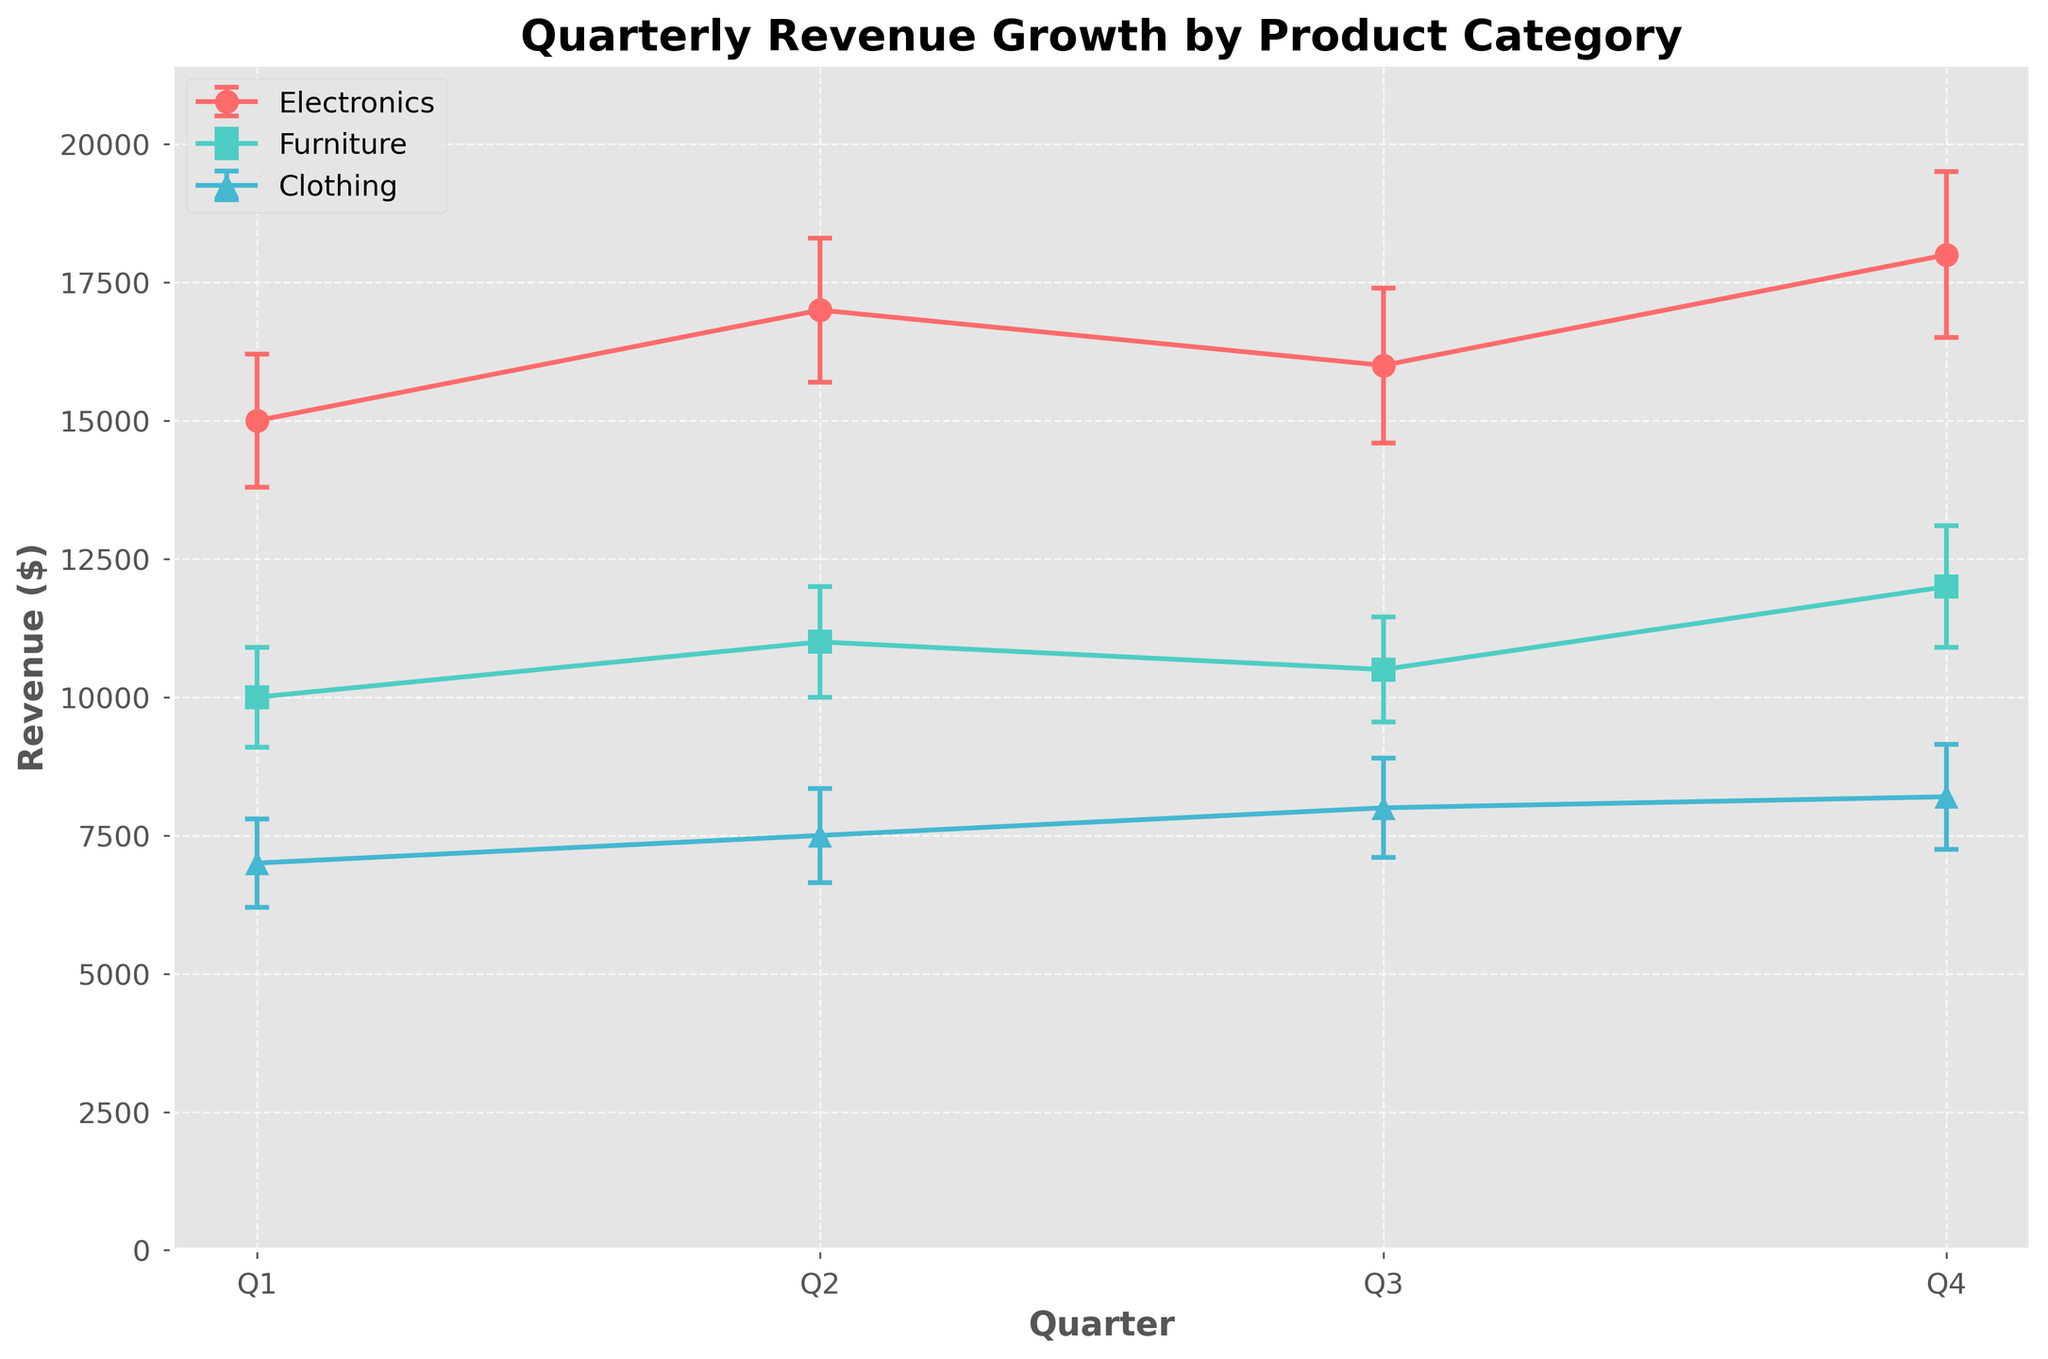Quarterly Revenue Growth by Product Category The title of the figure is centered at the top and indicates what the figure is about
Answer: Quarterly Revenue Growth by Product Category What are the categories compared in the figure? The figure shows separate lines for each product category, indicated by different colors and markers in the legend
Answer: Electronics, Furniture, Clothing Which quarter has the highest revenue for Electronics? By looking at the Electronics line, the revenue is highest in Q4, with the data point reaching its peak in Q4
Answer: Q4 What is the revenue for Furniture in Q2? Referring to the Furniture line, the revenue value for Q2 is plotted and shown on the y-axis
Answer: 11000 How does the Clothing category revenue change from Q1 to Q4? The Clothing line indicates increasing revenue values from Q1 to Q4, which can be traced visually along the x-axis
Answer: It increases What is the average revenue for Electronics over all quarters? Add the revenue values for each quarter for Electronics and divide by 4: (15000 + 17000 + 16000 + 18000) / 4
Answer: 16500 Which product category shows the smallest error range in Q3? Look at the error bars for each category in Q3; the Furniture category has the shortest error bars in that quarter
Answer: Furniture What is the difference in revenue between Electronics and Furniture in Q4? Subtract Furniture's revenue from Electronics' revenue in Q4: 18000 - 12000
Answer: 6000 Which product category had an increase in revenue every quarter? Trace the line for each product category and note which one shows a consistent rise in revenue values each quarter
Answer: Clothing Is the error bar for Electricity in Q2 larger or smaller than the error bar for Clothing in Q4? Compare the length of the error bars for Electricity in Q2 and Clothing in Q4 visually by looking at how far they extend above and below their respective points
Answer: Larger How do the revenue trends of Electronics and Furniture compare over the quarters? Both categories show a general increasing trend, but Electronics has more fluctuation in its revenue compared to Furniture, which has a steadier increase
Answer: Both increase, but Electronics fluctuates more 